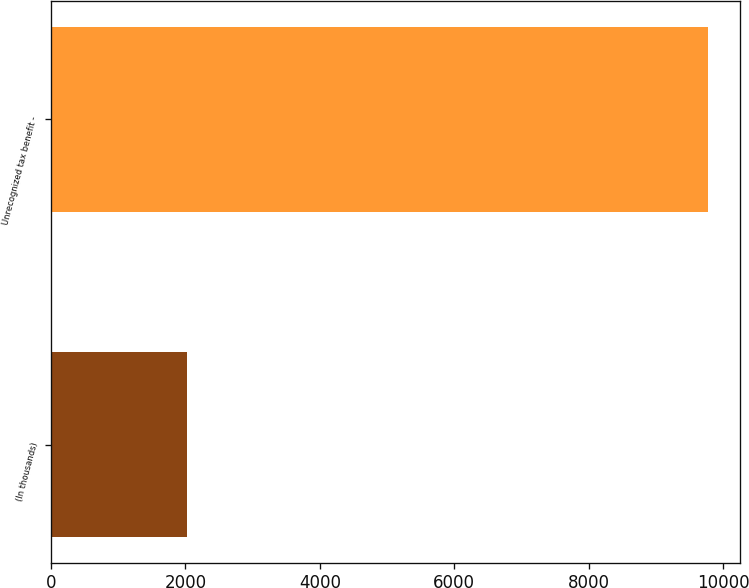<chart> <loc_0><loc_0><loc_500><loc_500><bar_chart><fcel>(In thousands)<fcel>Unrecognized tax benefit -<nl><fcel>2016<fcel>9769<nl></chart> 